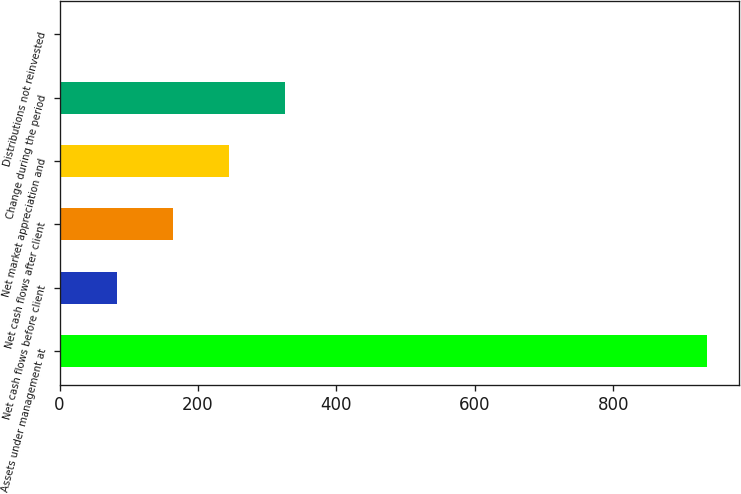Convert chart. <chart><loc_0><loc_0><loc_500><loc_500><bar_chart><fcel>Assets under management at<fcel>Net cash flows before client<fcel>Net cash flows after client<fcel>Net market appreciation and<fcel>Change during the period<fcel>Distributions not reinvested<nl><fcel>935.16<fcel>82.52<fcel>163.44<fcel>244.36<fcel>325.28<fcel>1.6<nl></chart> 